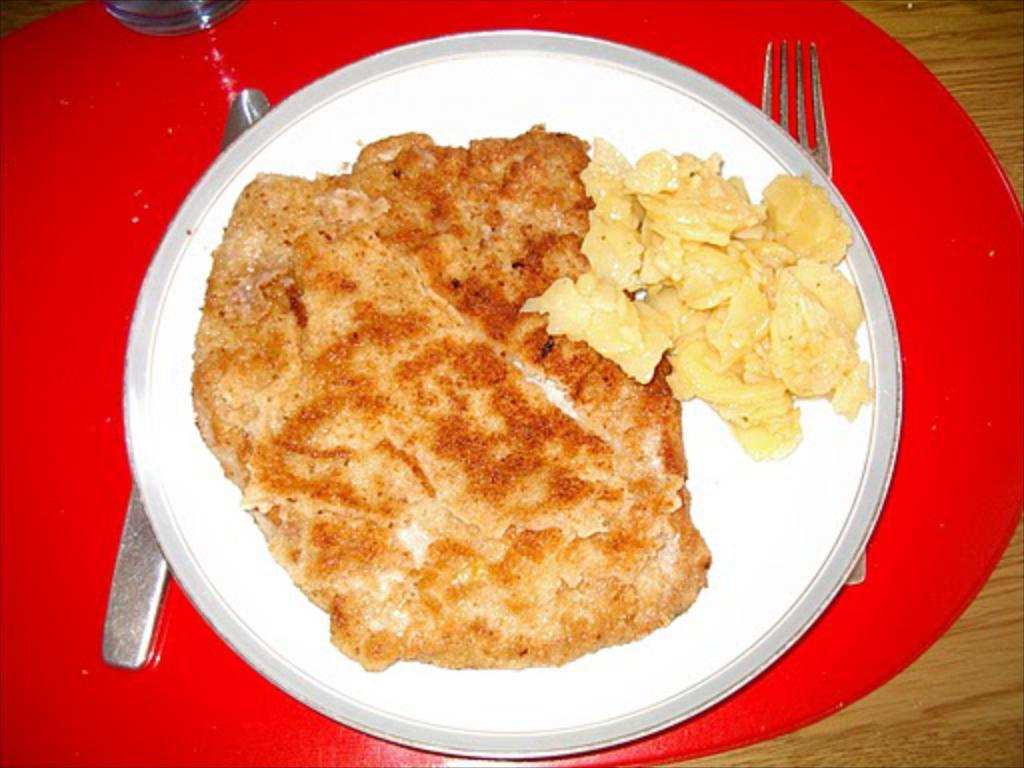What object is present on the tray in the image? There is a knife, a fork, a glass, and a plate on the tray in the image. What is on the plate in the image? There is food on the plate in the image. Where is the tray located in the image? The tray is on a table on the left side of the image. What type of card is being used to mine for resources in the image? There is no card or mining activity present in the image; it features a tray with various items on a table. 